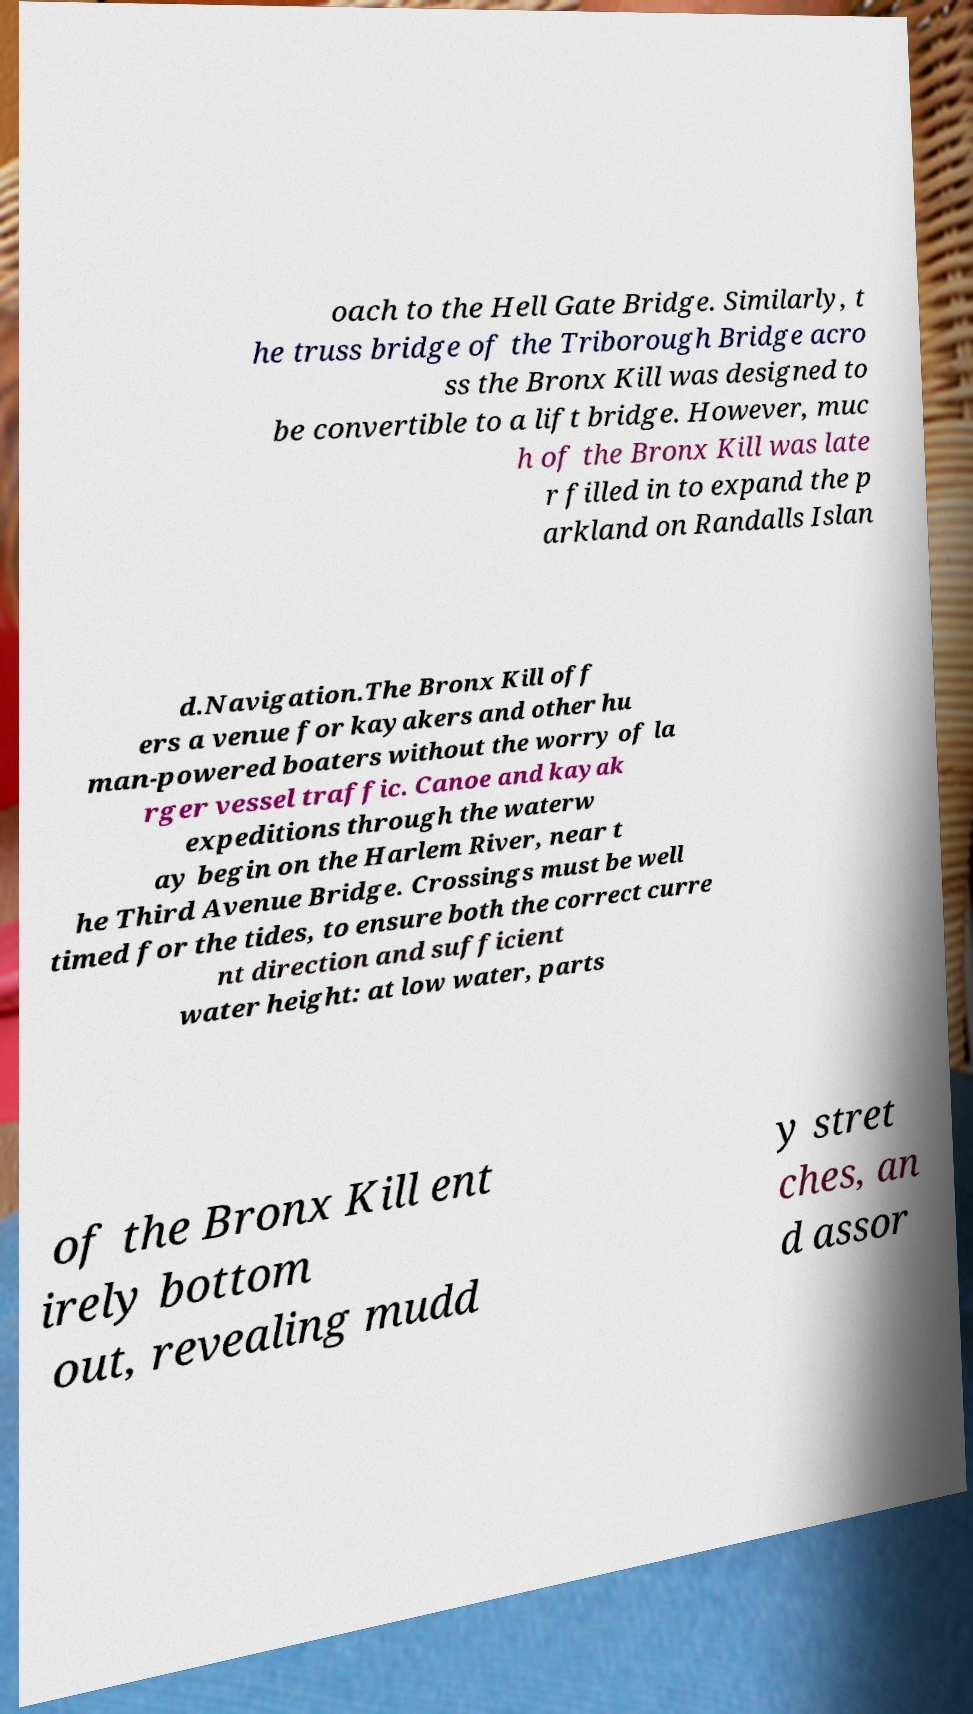For documentation purposes, I need the text within this image transcribed. Could you provide that? oach to the Hell Gate Bridge. Similarly, t he truss bridge of the Triborough Bridge acro ss the Bronx Kill was designed to be convertible to a lift bridge. However, muc h of the Bronx Kill was late r filled in to expand the p arkland on Randalls Islan d.Navigation.The Bronx Kill off ers a venue for kayakers and other hu man-powered boaters without the worry of la rger vessel traffic. Canoe and kayak expeditions through the waterw ay begin on the Harlem River, near t he Third Avenue Bridge. Crossings must be well timed for the tides, to ensure both the correct curre nt direction and sufficient water height: at low water, parts of the Bronx Kill ent irely bottom out, revealing mudd y stret ches, an d assor 